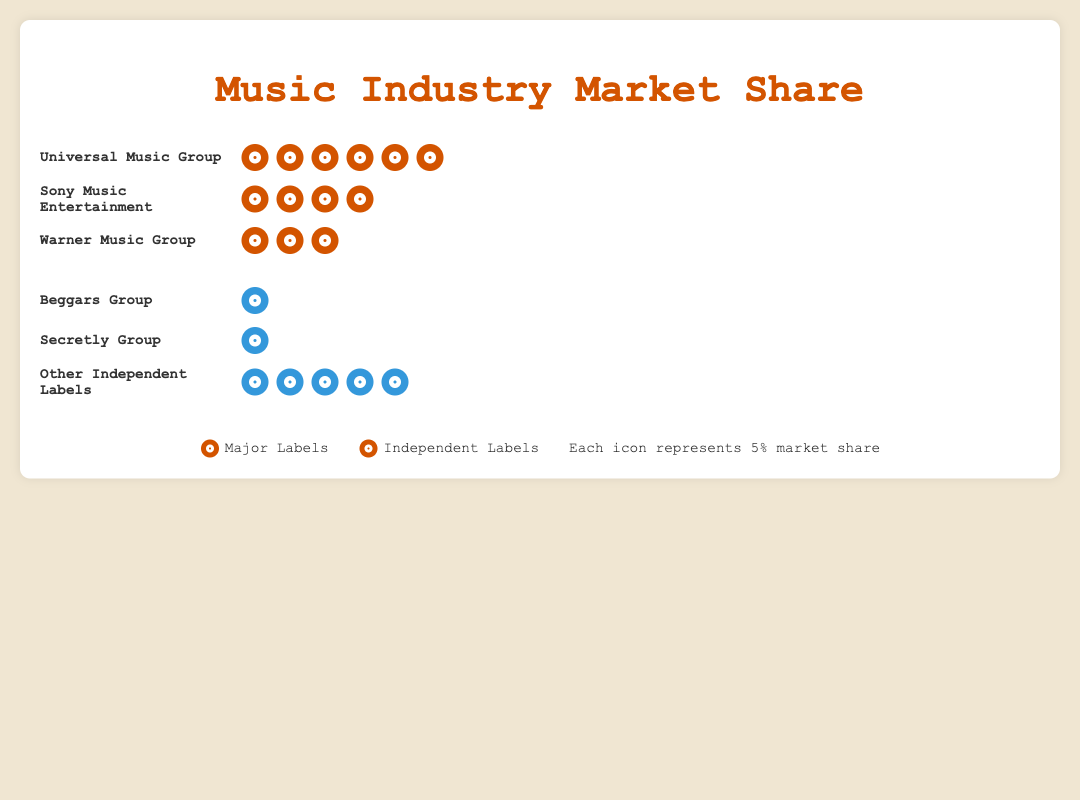What is the market share of Universal Music Group? Each record icon represents 5% market share. Universal Music Group has 6 icons, so 6 * 5% = 30%.
Answer: 30% How much more market share does Sony Music Entertainment have compared to Beggars Group? Sony Music Entertainment has 21% (4 icons), and Beggars Group has 3% (1 icon). The difference is 21% - 3% = 18%.
Answer: 18% Which label has the least market share among the major labels? Among the major labels: Universal Music Group (32%), Sony Music Entertainment (21%), and Warner Music Group (16%). Warner Music Group has the least with 16%.
Answer: Warner Music Group How many more icons does Universal Music Group have compared to Secretly Group? Universal Music Group has 6 icons, and Secretly Group has 1 icon. The difference is 6 - 1 = 5 icons.
Answer: 5 icons What is the total market share of all independent labels combined? Beggars Group has 3% (1 icon), Secretly Group has 2% (1 icon), and Other Independent Labels have 26% (5 icons). The total is 3% + 2% + 26% = 31%.
Answer: 31% Compare the market share of major labels versus independent labels. Which category has a higher market share and by how much? Major labels: Universal (32%), Sony (21%), Warner (16%) totaling 32% + 21% + 16% = 69%. Independent labels: Beggars (3%), Secretly (2%), Other Independent (26%), totaling 3% + 2% + 26% = 31%. Major labels have a higher market share by 69% - 31% = 38%.
Answer: Major labels by 38% What is the combined market share of Sony Music Entertainment and Warner Music Group? Sony Music Entertainment has 21% (4 icons) and Warner Music Group has 16% (3 icons). Combined, they have 21% + 16% = 37%.
Answer: 37% How many total record icons are there in the isotype plot? Major labels: 6 (Universal) + 4 (Sony) + 3 (Warner) = 13 icons. Independent labels: 1 (Beggars) + 1 (Secretly) + 5 (Other Independent) = 7 icons. In total, there are 13 + 7 = 20 icons.
Answer: 20 icons Which label among the independent labels has the largest market share? Among the independent labels, Beggars Group (3%), Secretly Group (2%), and Other Independent Labels (26%). Other Independent Labels have the largest market share with 26%.
Answer: Other Independent Labels Considering the isotype plot, what percentage does each icon represent, and how did you determine it? Each icon represents 5% market share as stated in the legend. This helps to easily estimate and visualize the market share each label holds.
Answer: 5% 